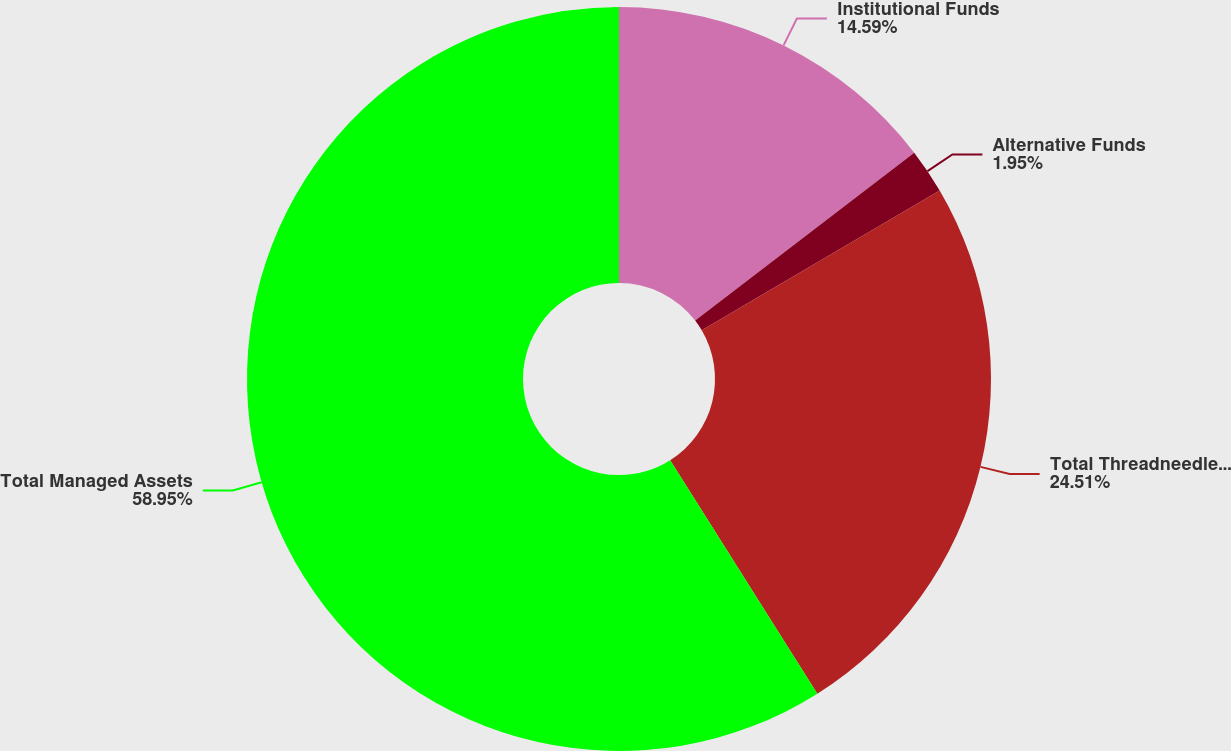Convert chart. <chart><loc_0><loc_0><loc_500><loc_500><pie_chart><fcel>Institutional Funds<fcel>Alternative Funds<fcel>Total Threadneedle Managed<fcel>Total Managed Assets<nl><fcel>14.59%<fcel>1.95%<fcel>24.51%<fcel>58.95%<nl></chart> 